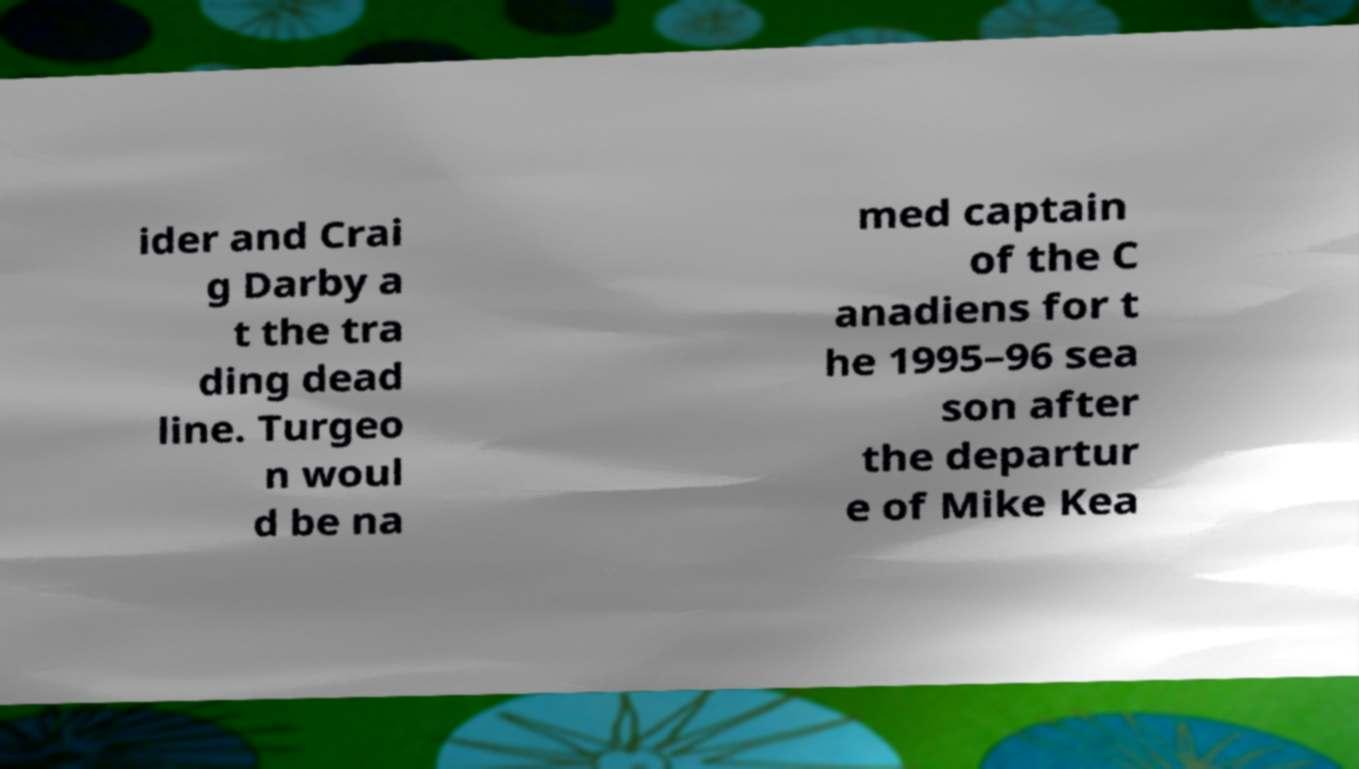Could you extract and type out the text from this image? ider and Crai g Darby a t the tra ding dead line. Turgeo n woul d be na med captain of the C anadiens for t he 1995–96 sea son after the departur e of Mike Kea 